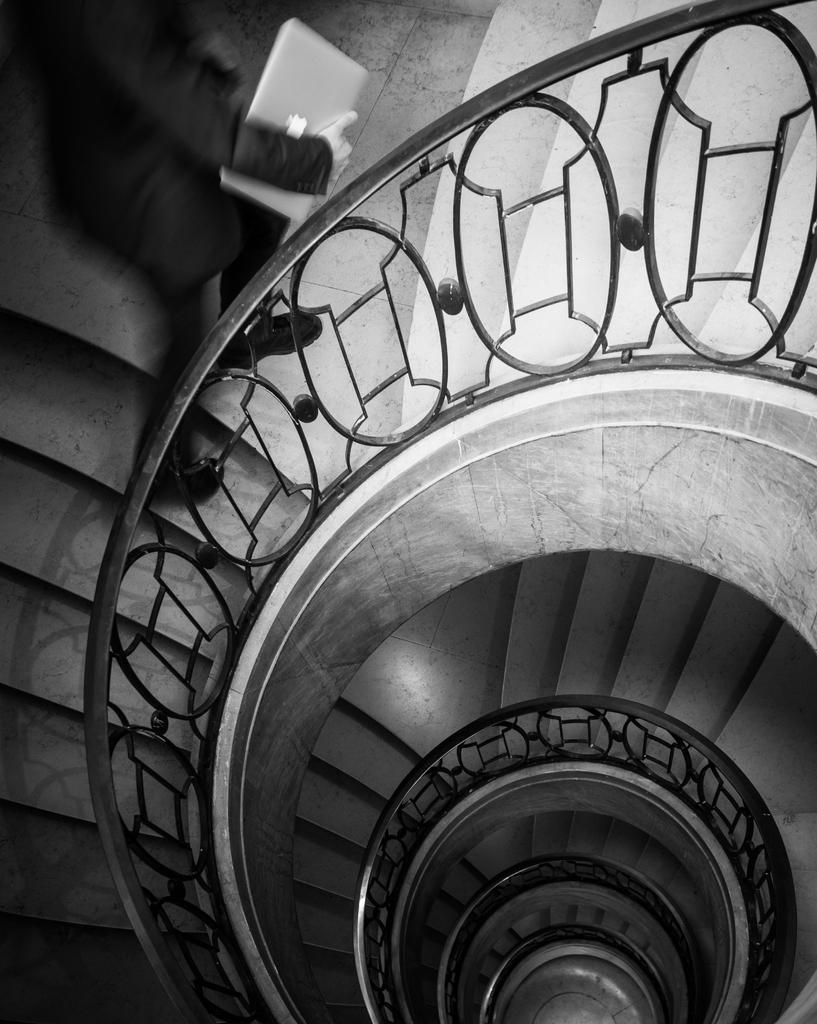Please provide a concise description of this image. In this picture I can see the stairs and I see the railing and on the left top of this image I see a person who is holding a laptop and I see that this is a black and white picture. 